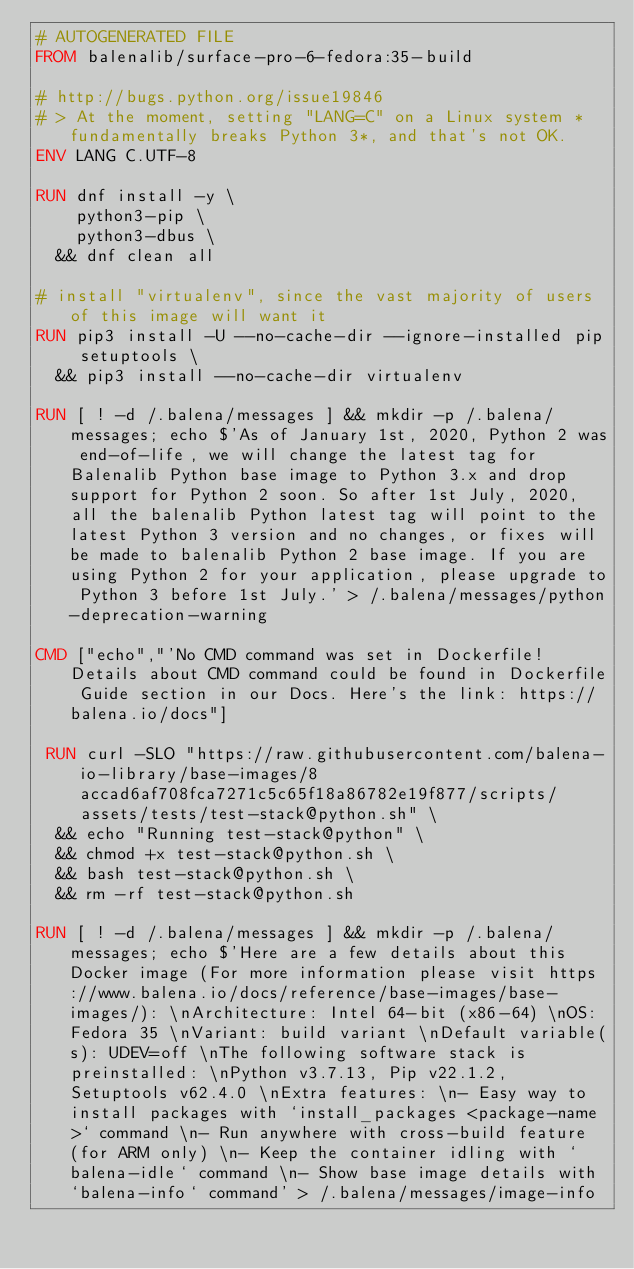<code> <loc_0><loc_0><loc_500><loc_500><_Dockerfile_># AUTOGENERATED FILE
FROM balenalib/surface-pro-6-fedora:35-build

# http://bugs.python.org/issue19846
# > At the moment, setting "LANG=C" on a Linux system *fundamentally breaks Python 3*, and that's not OK.
ENV LANG C.UTF-8

RUN dnf install -y \
		python3-pip \
		python3-dbus \
	&& dnf clean all

# install "virtualenv", since the vast majority of users of this image will want it
RUN pip3 install -U --no-cache-dir --ignore-installed pip setuptools \
	&& pip3 install --no-cache-dir virtualenv

RUN [ ! -d /.balena/messages ] && mkdir -p /.balena/messages; echo $'As of January 1st, 2020, Python 2 was end-of-life, we will change the latest tag for Balenalib Python base image to Python 3.x and drop support for Python 2 soon. So after 1st July, 2020, all the balenalib Python latest tag will point to the latest Python 3 version and no changes, or fixes will be made to balenalib Python 2 base image. If you are using Python 2 for your application, please upgrade to Python 3 before 1st July.' > /.balena/messages/python-deprecation-warning

CMD ["echo","'No CMD command was set in Dockerfile! Details about CMD command could be found in Dockerfile Guide section in our Docs. Here's the link: https://balena.io/docs"]

 RUN curl -SLO "https://raw.githubusercontent.com/balena-io-library/base-images/8accad6af708fca7271c5c65f18a86782e19f877/scripts/assets/tests/test-stack@python.sh" \
  && echo "Running test-stack@python" \
  && chmod +x test-stack@python.sh \
  && bash test-stack@python.sh \
  && rm -rf test-stack@python.sh 

RUN [ ! -d /.balena/messages ] && mkdir -p /.balena/messages; echo $'Here are a few details about this Docker image (For more information please visit https://www.balena.io/docs/reference/base-images/base-images/): \nArchitecture: Intel 64-bit (x86-64) \nOS: Fedora 35 \nVariant: build variant \nDefault variable(s): UDEV=off \nThe following software stack is preinstalled: \nPython v3.7.13, Pip v22.1.2, Setuptools v62.4.0 \nExtra features: \n- Easy way to install packages with `install_packages <package-name>` command \n- Run anywhere with cross-build feature  (for ARM only) \n- Keep the container idling with `balena-idle` command \n- Show base image details with `balena-info` command' > /.balena/messages/image-info</code> 